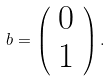Convert formula to latex. <formula><loc_0><loc_0><loc_500><loc_500>b = \left ( \begin{array} { c } 0 \\ 1 \end{array} \right ) .</formula> 